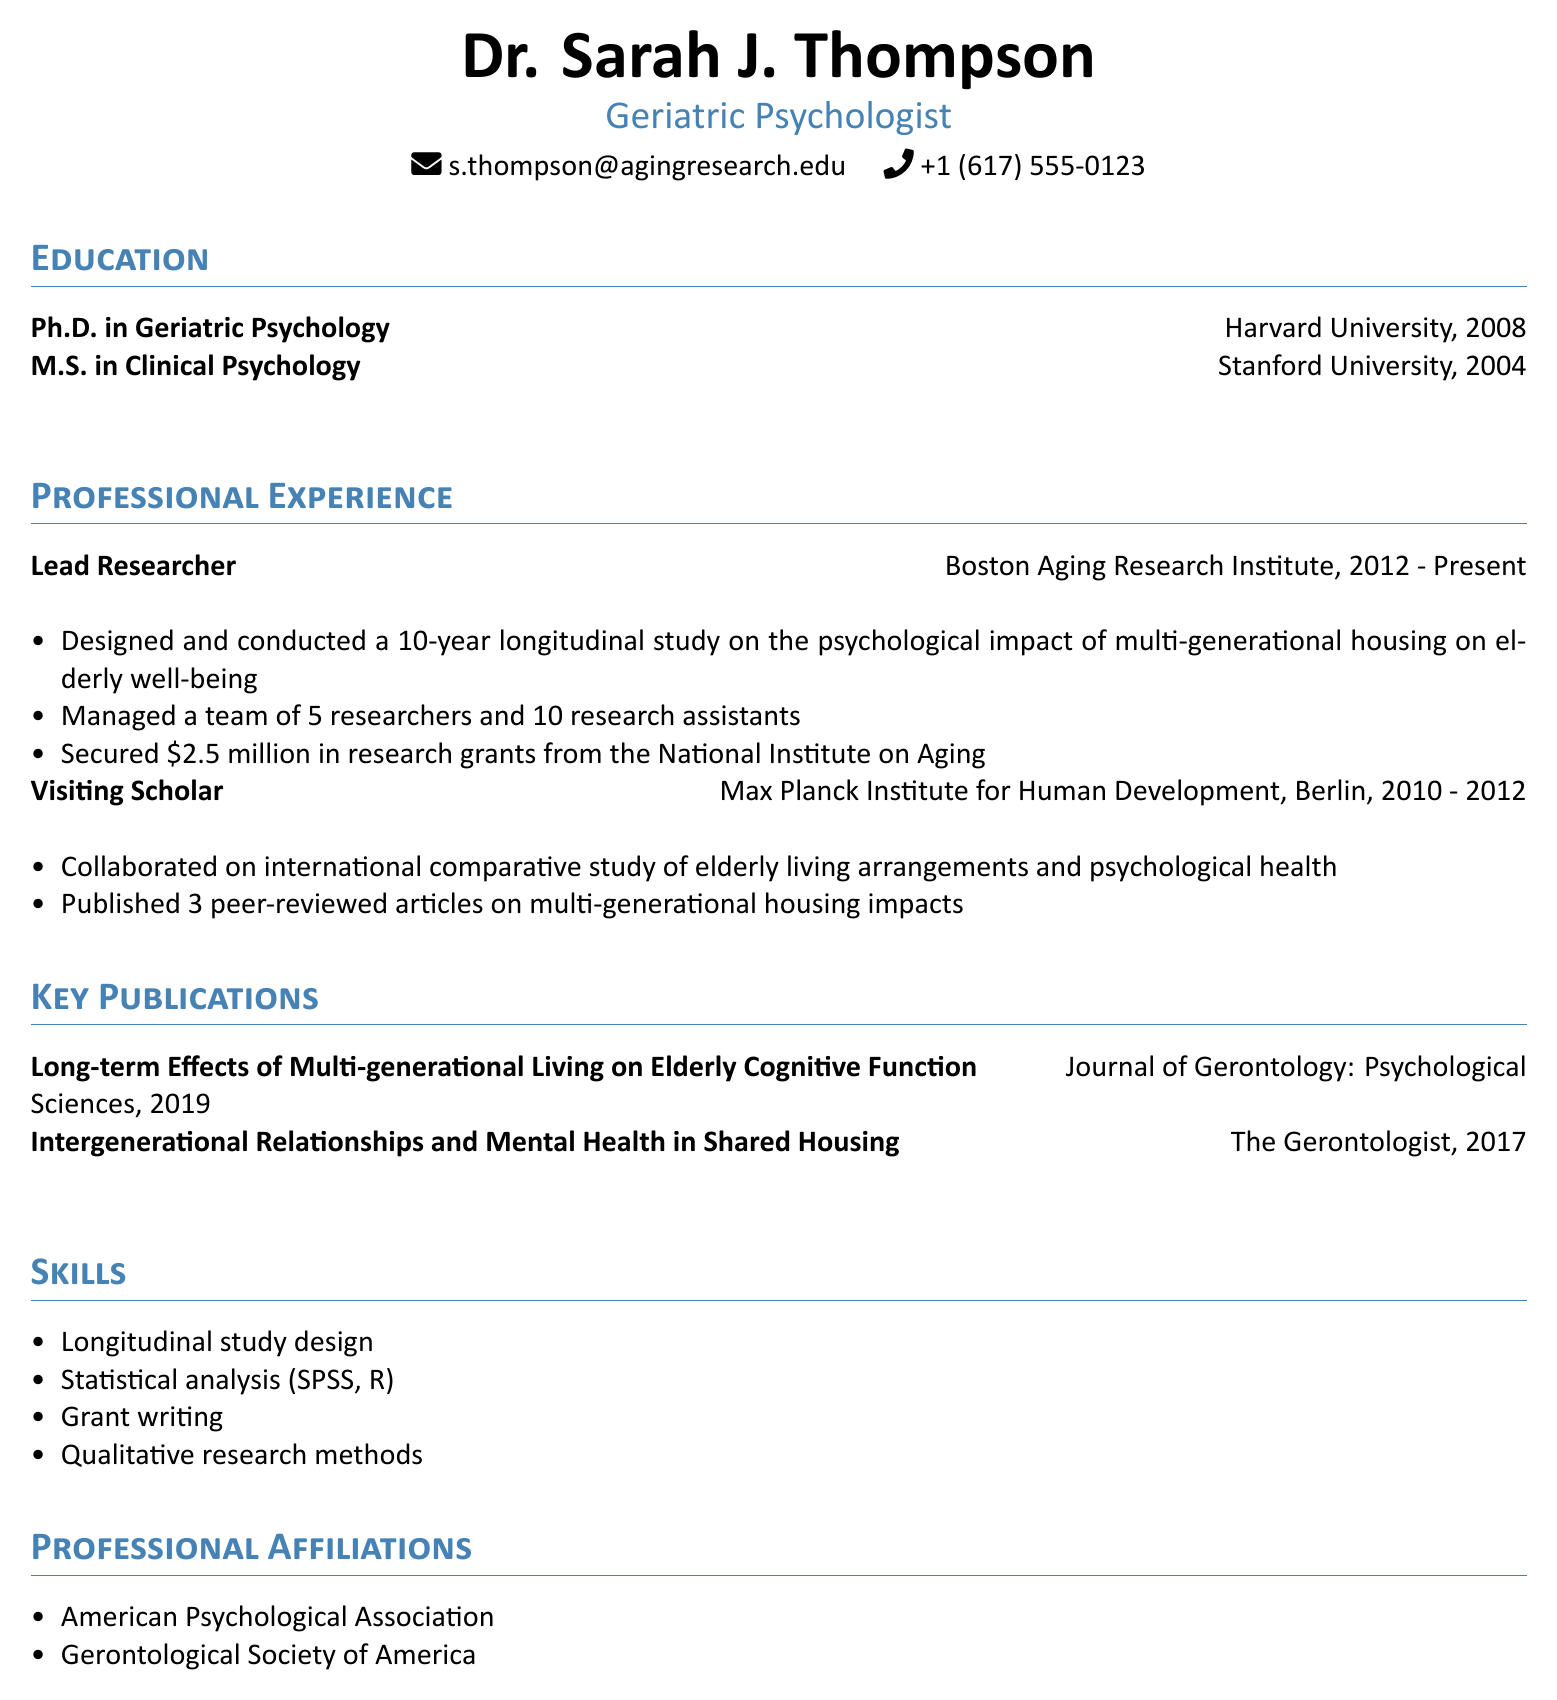What is the title held by Dr. Sarah J. Thompson? The title listed in the document is the professional designation of Dr. Sarah J. Thompson.
Answer: Geriatric Psychologist What year did Dr. Thompson complete her Ph.D.? The document specifies the year when Dr. Thompson earned her doctoral degree.
Answer: 2008 How many years did Dr. Thompson conduct her longitudinal study? The document states the duration of the longitudinal study that Dr. Thompson designed and conducted.
Answer: 10-year What institution did Dr. Thompson work for as a Lead Researcher? The document identifies the organization where Dr. Thompson has held her current position.
Answer: Boston Aging Research Institute What amount did Dr. Thompson secure in research grants? The document provides the exact figure of research grants obtained by Dr. Thompson.
Answer: $2.5 million How many peer-reviewed articles did Dr. Thompson publish as a Visiting Scholar? The document indicates the number of articles published during her time at the Max Planck Institute.
Answer: 3 What is one of the skills listed in the CV related to research methods? The document highlights specific skills that Dr. Thompson possesses related to her field of work.
Answer: Qualitative research methods Which professional organization is Dr. Thompson affiliated with? The document lists one of the professional bodies with which Dr. Thompson has a membership.
Answer: American Psychological Association 